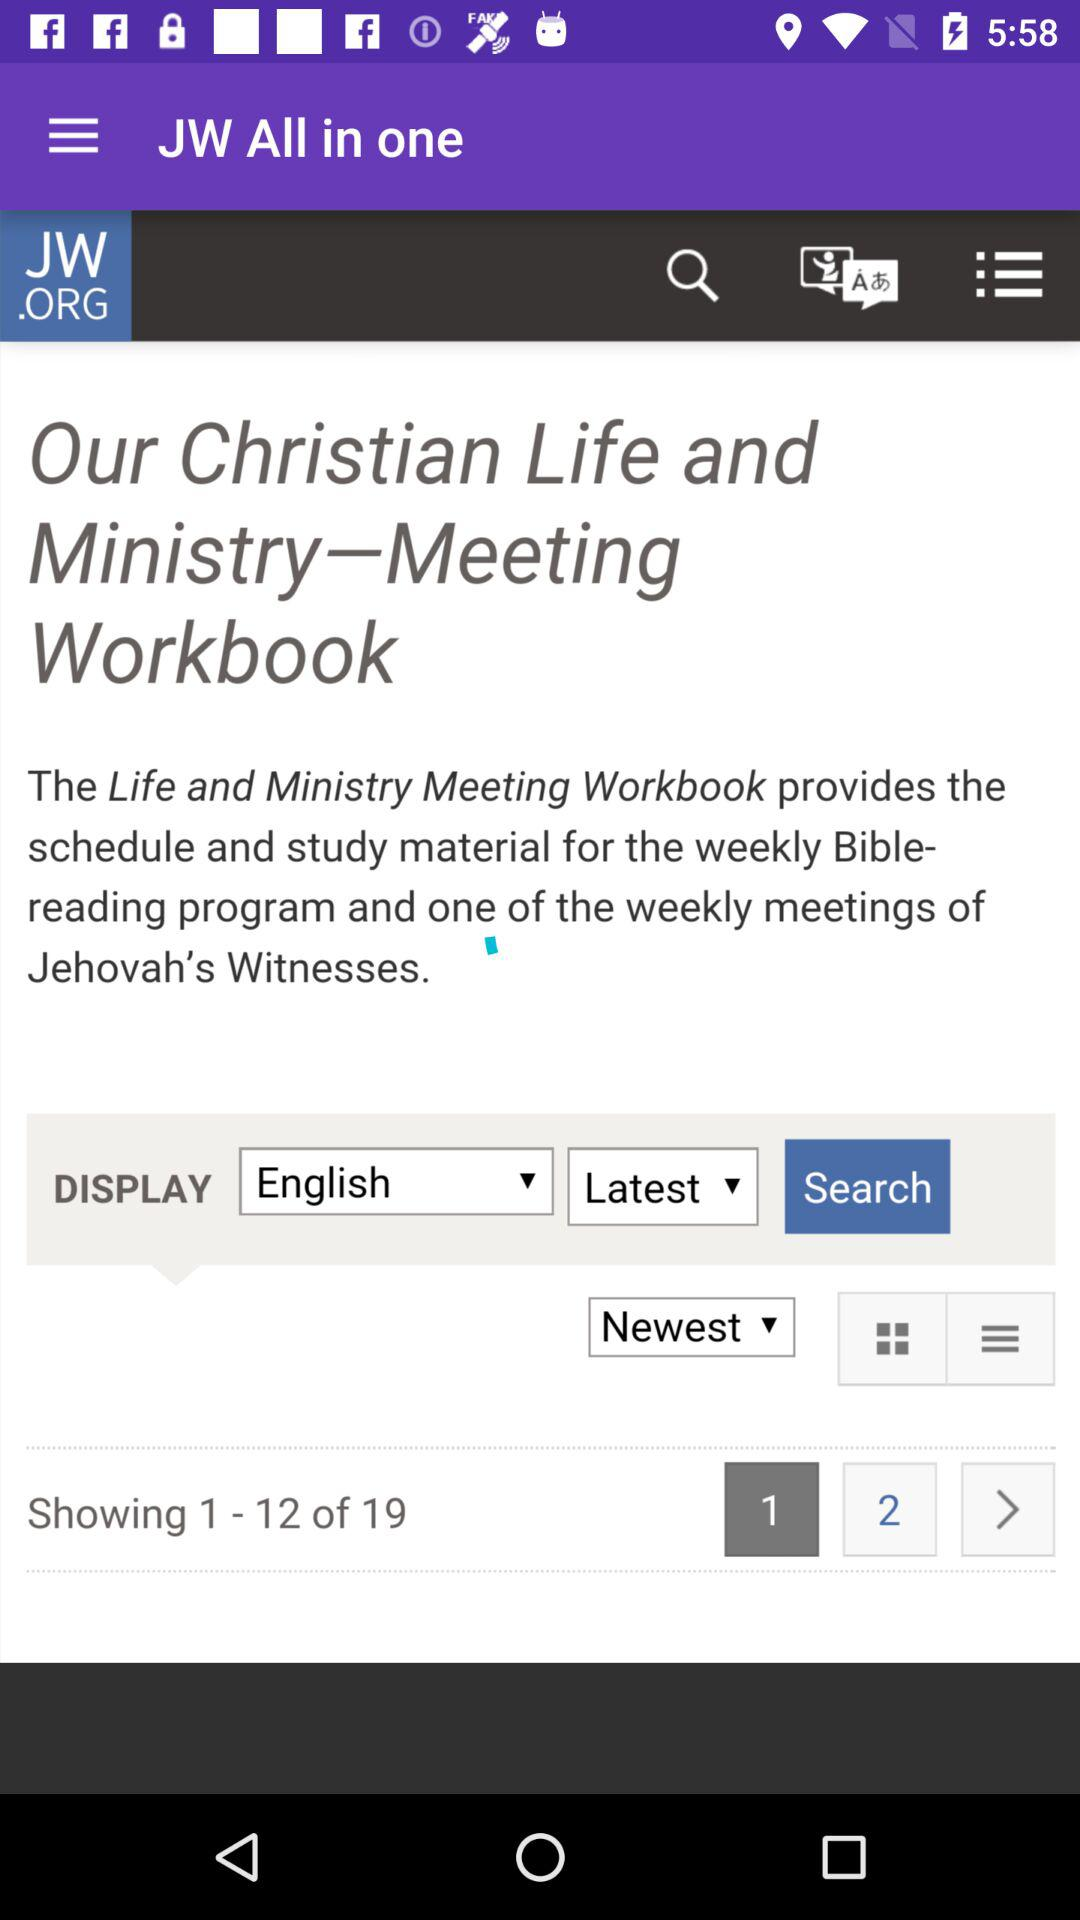What language is selected? The selected language is English. 